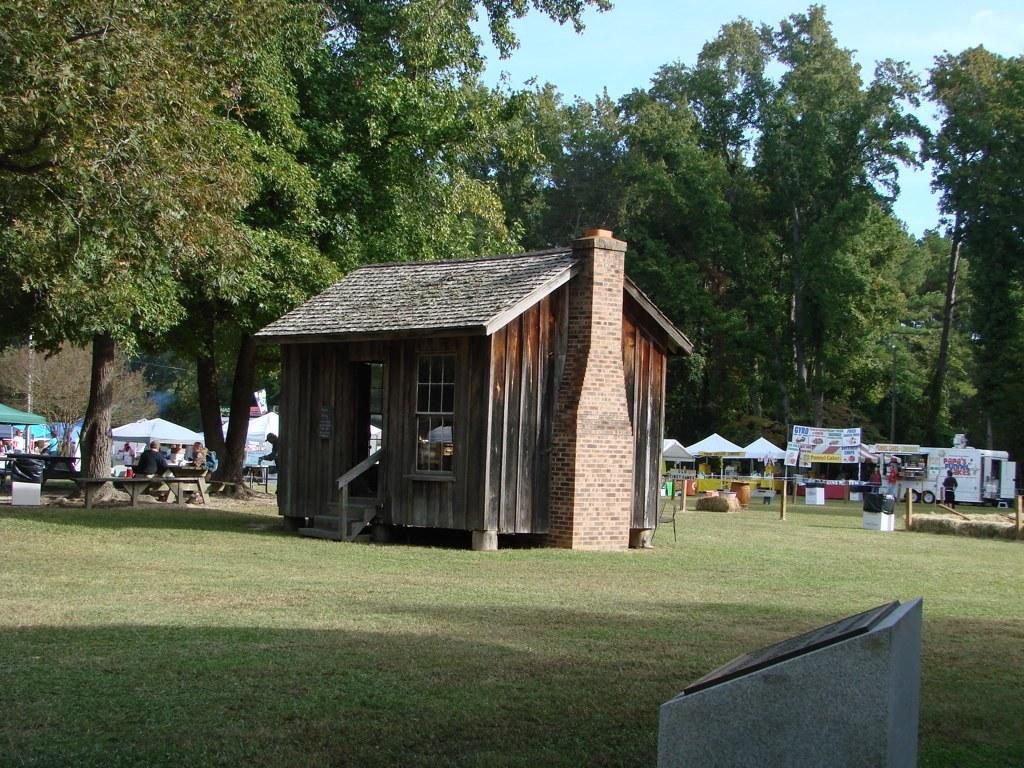What type of structure is in the image? There is a house in the image. What is located behind the house? There are tents behind the house. What can be seen in the background of the image? There is a group of trees and tables and chairs in the background. Are there any people visible in the image? Yes, there are people visible in the background. What type of doll can be seen playing with sand in the image? There is no doll or sand present in the image. 